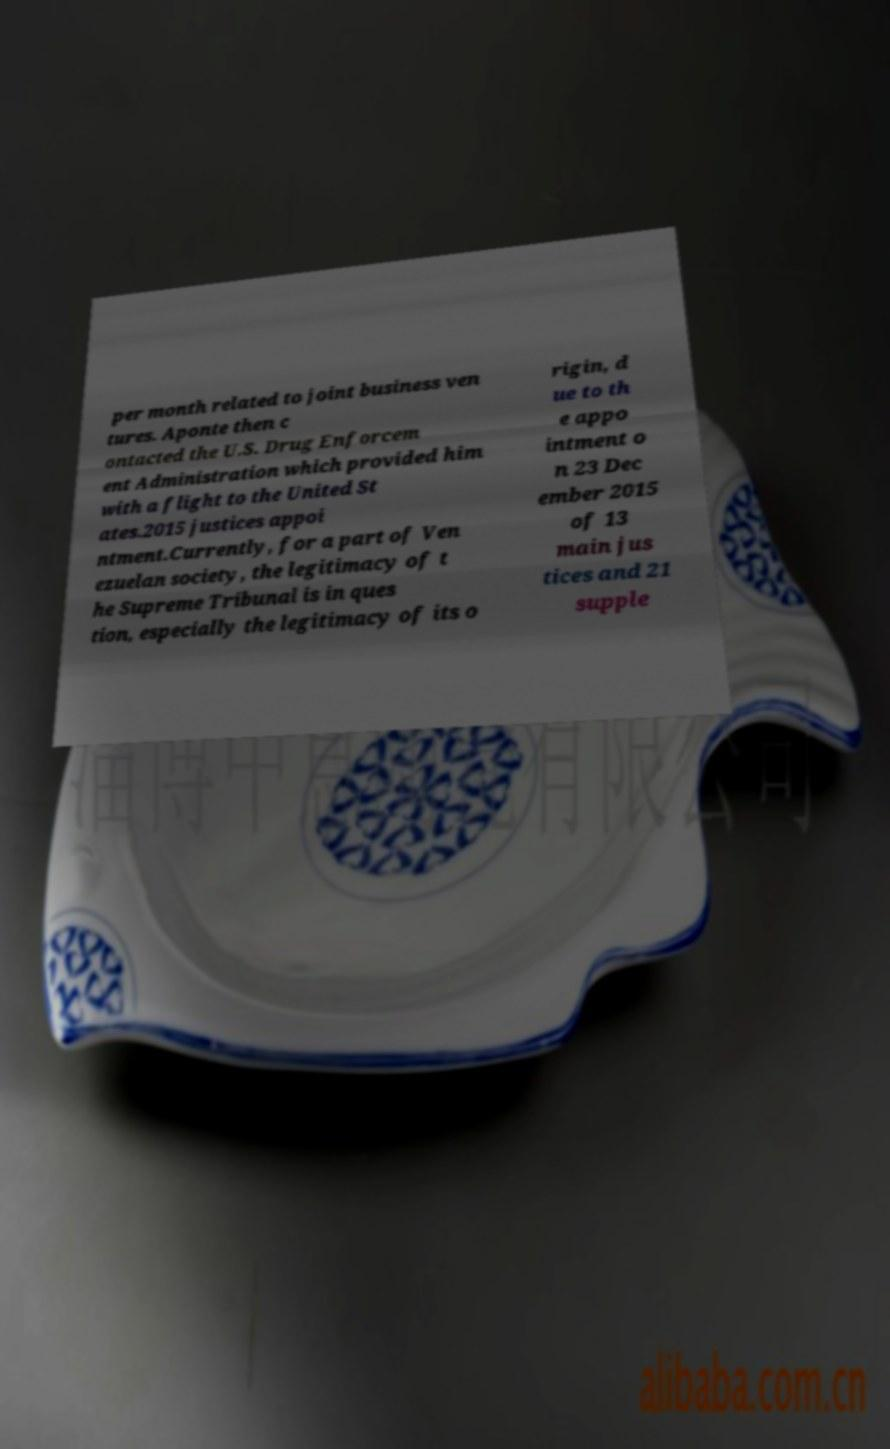Please identify and transcribe the text found in this image. per month related to joint business ven tures. Aponte then c ontacted the U.S. Drug Enforcem ent Administration which provided him with a flight to the United St ates.2015 justices appoi ntment.Currently, for a part of Ven ezuelan society, the legitimacy of t he Supreme Tribunal is in ques tion, especially the legitimacy of its o rigin, d ue to th e appo intment o n 23 Dec ember 2015 of 13 main jus tices and 21 supple 